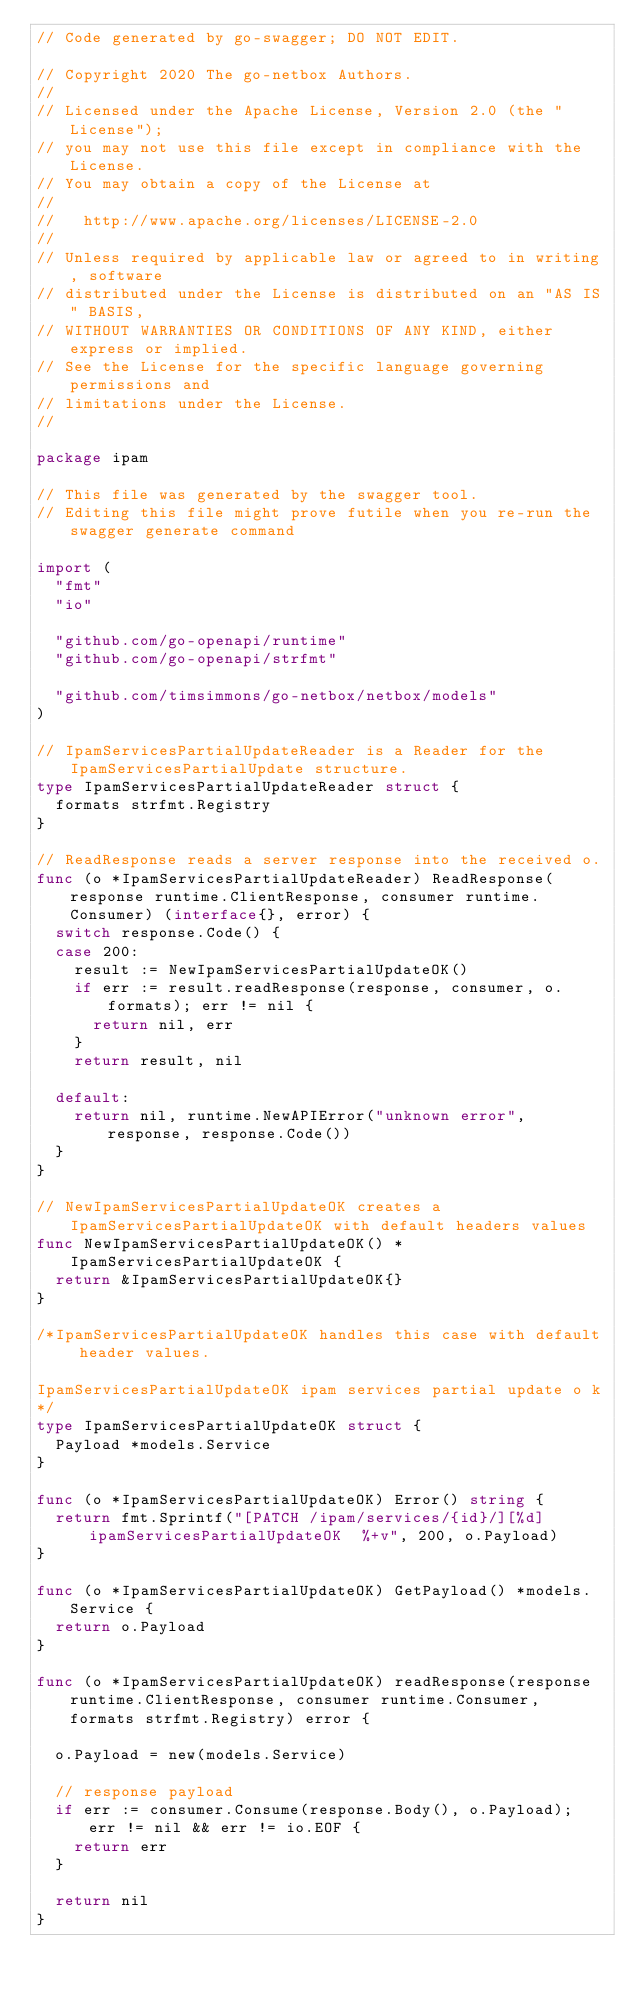Convert code to text. <code><loc_0><loc_0><loc_500><loc_500><_Go_>// Code generated by go-swagger; DO NOT EDIT.

// Copyright 2020 The go-netbox Authors.
//
// Licensed under the Apache License, Version 2.0 (the "License");
// you may not use this file except in compliance with the License.
// You may obtain a copy of the License at
//
//   http://www.apache.org/licenses/LICENSE-2.0
//
// Unless required by applicable law or agreed to in writing, software
// distributed under the License is distributed on an "AS IS" BASIS,
// WITHOUT WARRANTIES OR CONDITIONS OF ANY KIND, either express or implied.
// See the License for the specific language governing permissions and
// limitations under the License.
//

package ipam

// This file was generated by the swagger tool.
// Editing this file might prove futile when you re-run the swagger generate command

import (
	"fmt"
	"io"

	"github.com/go-openapi/runtime"
	"github.com/go-openapi/strfmt"

	"github.com/timsimmons/go-netbox/netbox/models"
)

// IpamServicesPartialUpdateReader is a Reader for the IpamServicesPartialUpdate structure.
type IpamServicesPartialUpdateReader struct {
	formats strfmt.Registry
}

// ReadResponse reads a server response into the received o.
func (o *IpamServicesPartialUpdateReader) ReadResponse(response runtime.ClientResponse, consumer runtime.Consumer) (interface{}, error) {
	switch response.Code() {
	case 200:
		result := NewIpamServicesPartialUpdateOK()
		if err := result.readResponse(response, consumer, o.formats); err != nil {
			return nil, err
		}
		return result, nil

	default:
		return nil, runtime.NewAPIError("unknown error", response, response.Code())
	}
}

// NewIpamServicesPartialUpdateOK creates a IpamServicesPartialUpdateOK with default headers values
func NewIpamServicesPartialUpdateOK() *IpamServicesPartialUpdateOK {
	return &IpamServicesPartialUpdateOK{}
}

/*IpamServicesPartialUpdateOK handles this case with default header values.

IpamServicesPartialUpdateOK ipam services partial update o k
*/
type IpamServicesPartialUpdateOK struct {
	Payload *models.Service
}

func (o *IpamServicesPartialUpdateOK) Error() string {
	return fmt.Sprintf("[PATCH /ipam/services/{id}/][%d] ipamServicesPartialUpdateOK  %+v", 200, o.Payload)
}

func (o *IpamServicesPartialUpdateOK) GetPayload() *models.Service {
	return o.Payload
}

func (o *IpamServicesPartialUpdateOK) readResponse(response runtime.ClientResponse, consumer runtime.Consumer, formats strfmt.Registry) error {

	o.Payload = new(models.Service)

	// response payload
	if err := consumer.Consume(response.Body(), o.Payload); err != nil && err != io.EOF {
		return err
	}

	return nil
}
</code> 